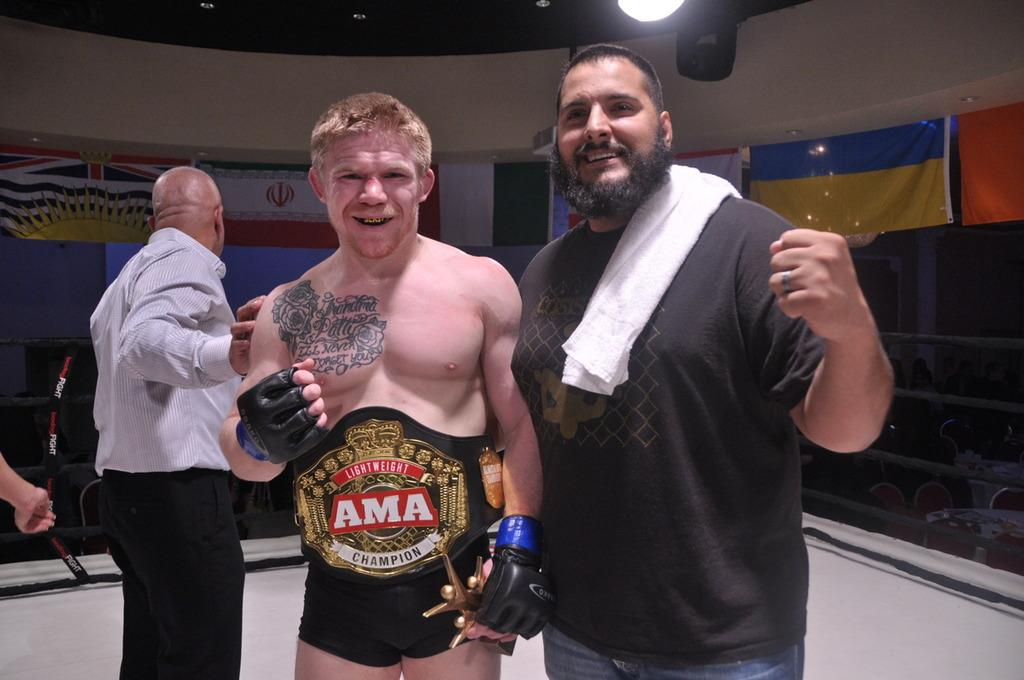<image>
Write a terse but informative summary of the picture. Some fighters standing around, one of whom is wearing a belt reading AMA> 